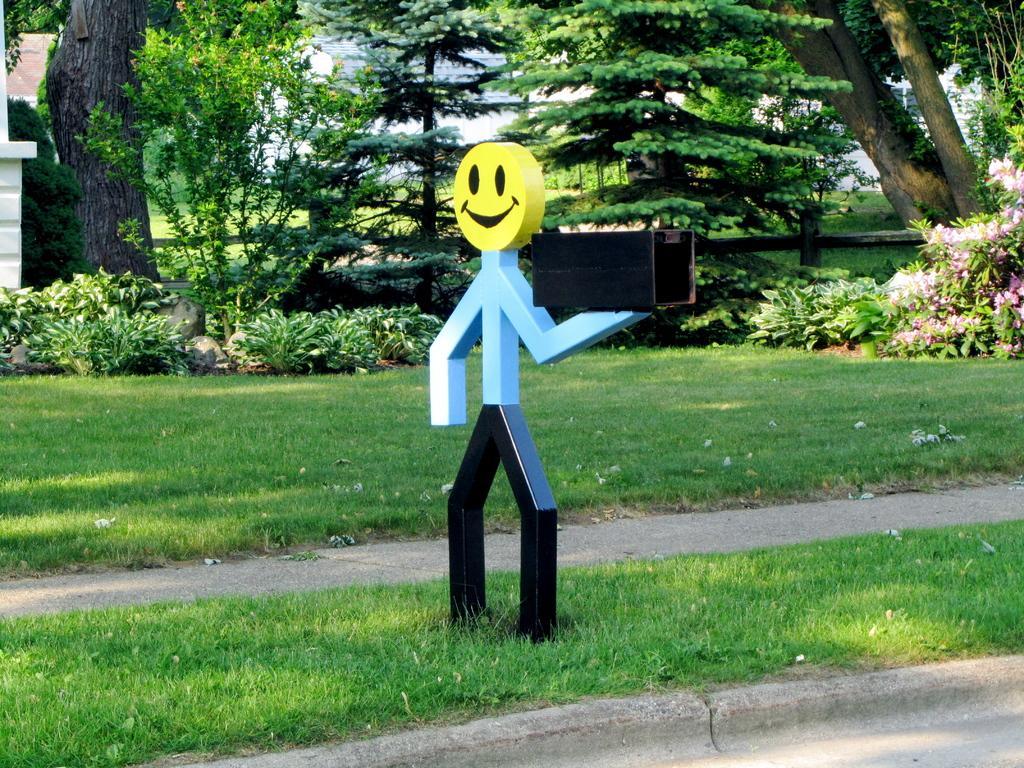Could you give a brief overview of what you see in this image? This is an outdoor picture. In this picture we can see a statue with a smiley face. This is a box in statue's hand. On the background we can see trees. This is a flower plant. These are plants. Here we can see grass in green colour. This is a path. 